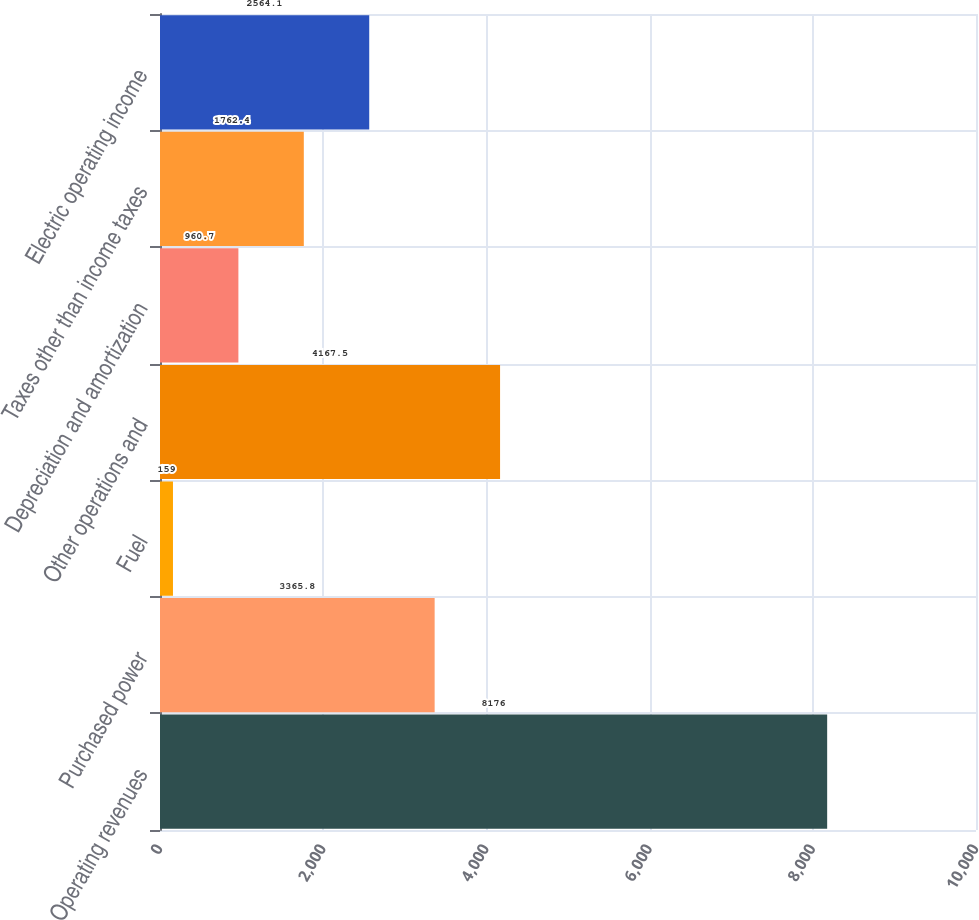Convert chart. <chart><loc_0><loc_0><loc_500><loc_500><bar_chart><fcel>Operating revenues<fcel>Purchased power<fcel>Fuel<fcel>Other operations and<fcel>Depreciation and amortization<fcel>Taxes other than income taxes<fcel>Electric operating income<nl><fcel>8176<fcel>3365.8<fcel>159<fcel>4167.5<fcel>960.7<fcel>1762.4<fcel>2564.1<nl></chart> 